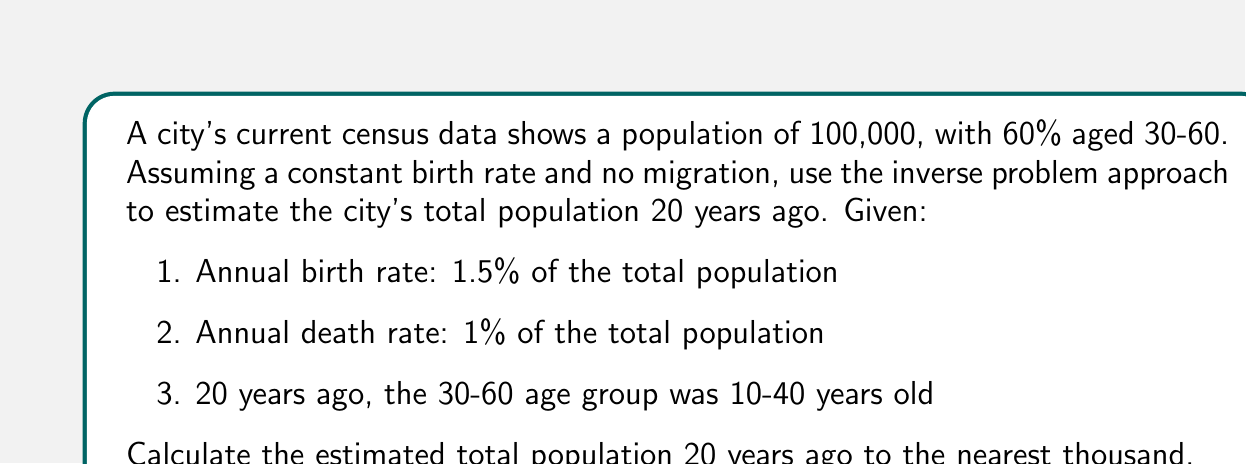Can you solve this math problem? Let's approach this step-by-step:

1) First, we need to set up our inverse problem. We're trying to reconstruct the past population ($P_0$) given the current population ($P_t$) after 20 years.

2) The general formula for population growth is:
   $P_t = P_0 * (1 + r)^t$
   Where $r$ is the net growth rate and $t$ is the number of years.

3) In our case, $r = 0.015 - 0.01 = 0.005$ (birth rate minus death rate)
   $t = 20$ years
   $P_t = 100,000$

4) Substituting into our formula:
   $100,000 = P_0 * (1 + 0.005)^{20}$

5) Solving for $P_0$:
   $P_0 = 100,000 / (1.005)^{20}$

6) Using a calculator:
   $P_0 = 100,000 / 1.1046 = 90,530$

7) However, we need to consider the age group information. The current 30-60 age group (60% of 100,000 = 60,000) was entirely present 20 years ago as the 10-40 age group.

8) If 60,000 people represent 60% of the current population, they likely represented a smaller percentage of the population 20 years ago due to births over the 20-year period.

9) A rough estimate would be that these 60,000 people represented about 70% of the population 20 years ago.

10) Therefore, we can estimate:
    $60,000 / 0.70 = 85,714$

11) This is close to our calculated value of 90,530, providing a good cross-check.

12) Rounding to the nearest thousand as requested: 86,000
Answer: 86,000 